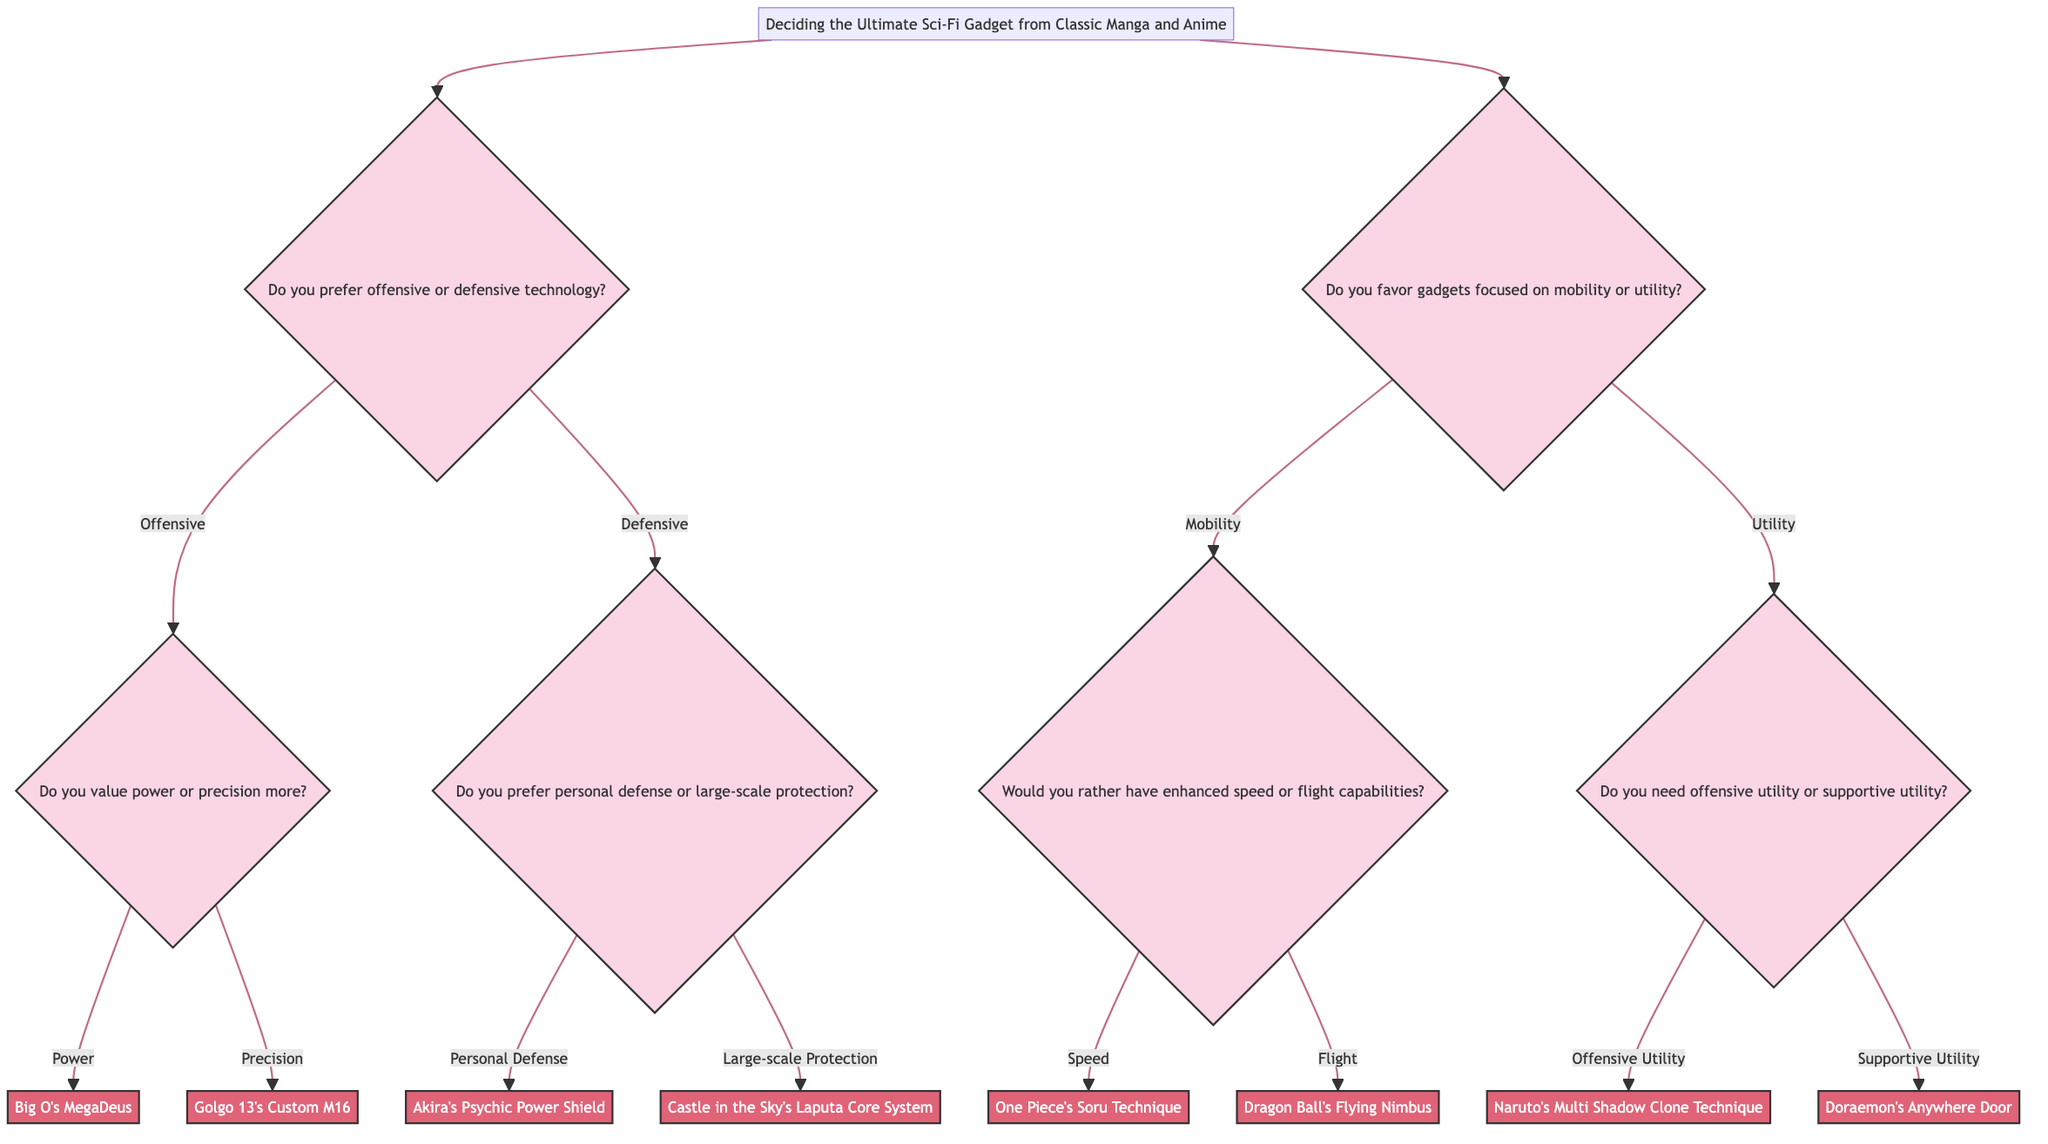What is the main purpose of the diagram? The main purpose of the diagram is to help users decide on the ultimate sci-fi gadget from classic manga and anime by navigating through their preferences and choices.
Answer: Deciding the Ultimate Sci-Fi Gadget from Classic Manga and Anime How many main categories of technology are present in the diagram? There are two main categories in the diagram: offensive or defensive technology, and mobility or utility gadgets.
Answer: 2 If a user chooses "Offensive" and then "Power," what gadget will they get? Following the path from "Offensive" to "Power," the resultant gadget at the end of this path is "Big O's MegaDeus."
Answer: Big O's MegaDeus What question follows "Do you prefer personal defense or large-scale protection?" After answering about personal or large-scale protection under defensive technology, there are no further questions; it leads directly to the gadgets.
Answer: None In the category of mobility, what are the two options presented? The two options for mobility are "enhanced speed" and "flight capabilities."
Answer: Enhanced speed or flight capabilities 